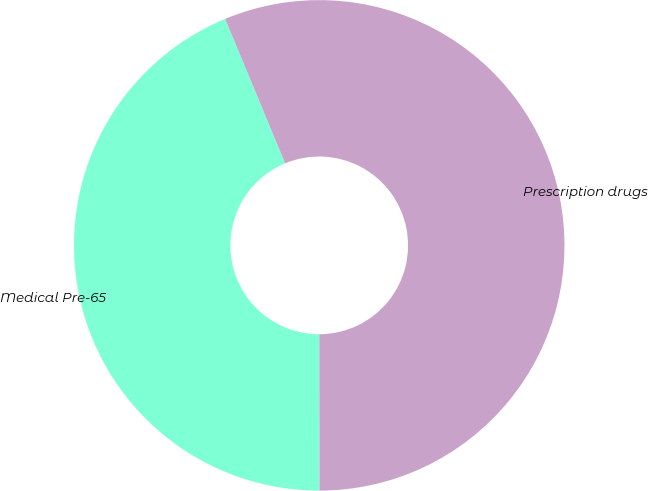<chart> <loc_0><loc_0><loc_500><loc_500><pie_chart><fcel>Medical Pre-65<fcel>Prescription drugs<nl><fcel>43.75%<fcel>56.25%<nl></chart> 